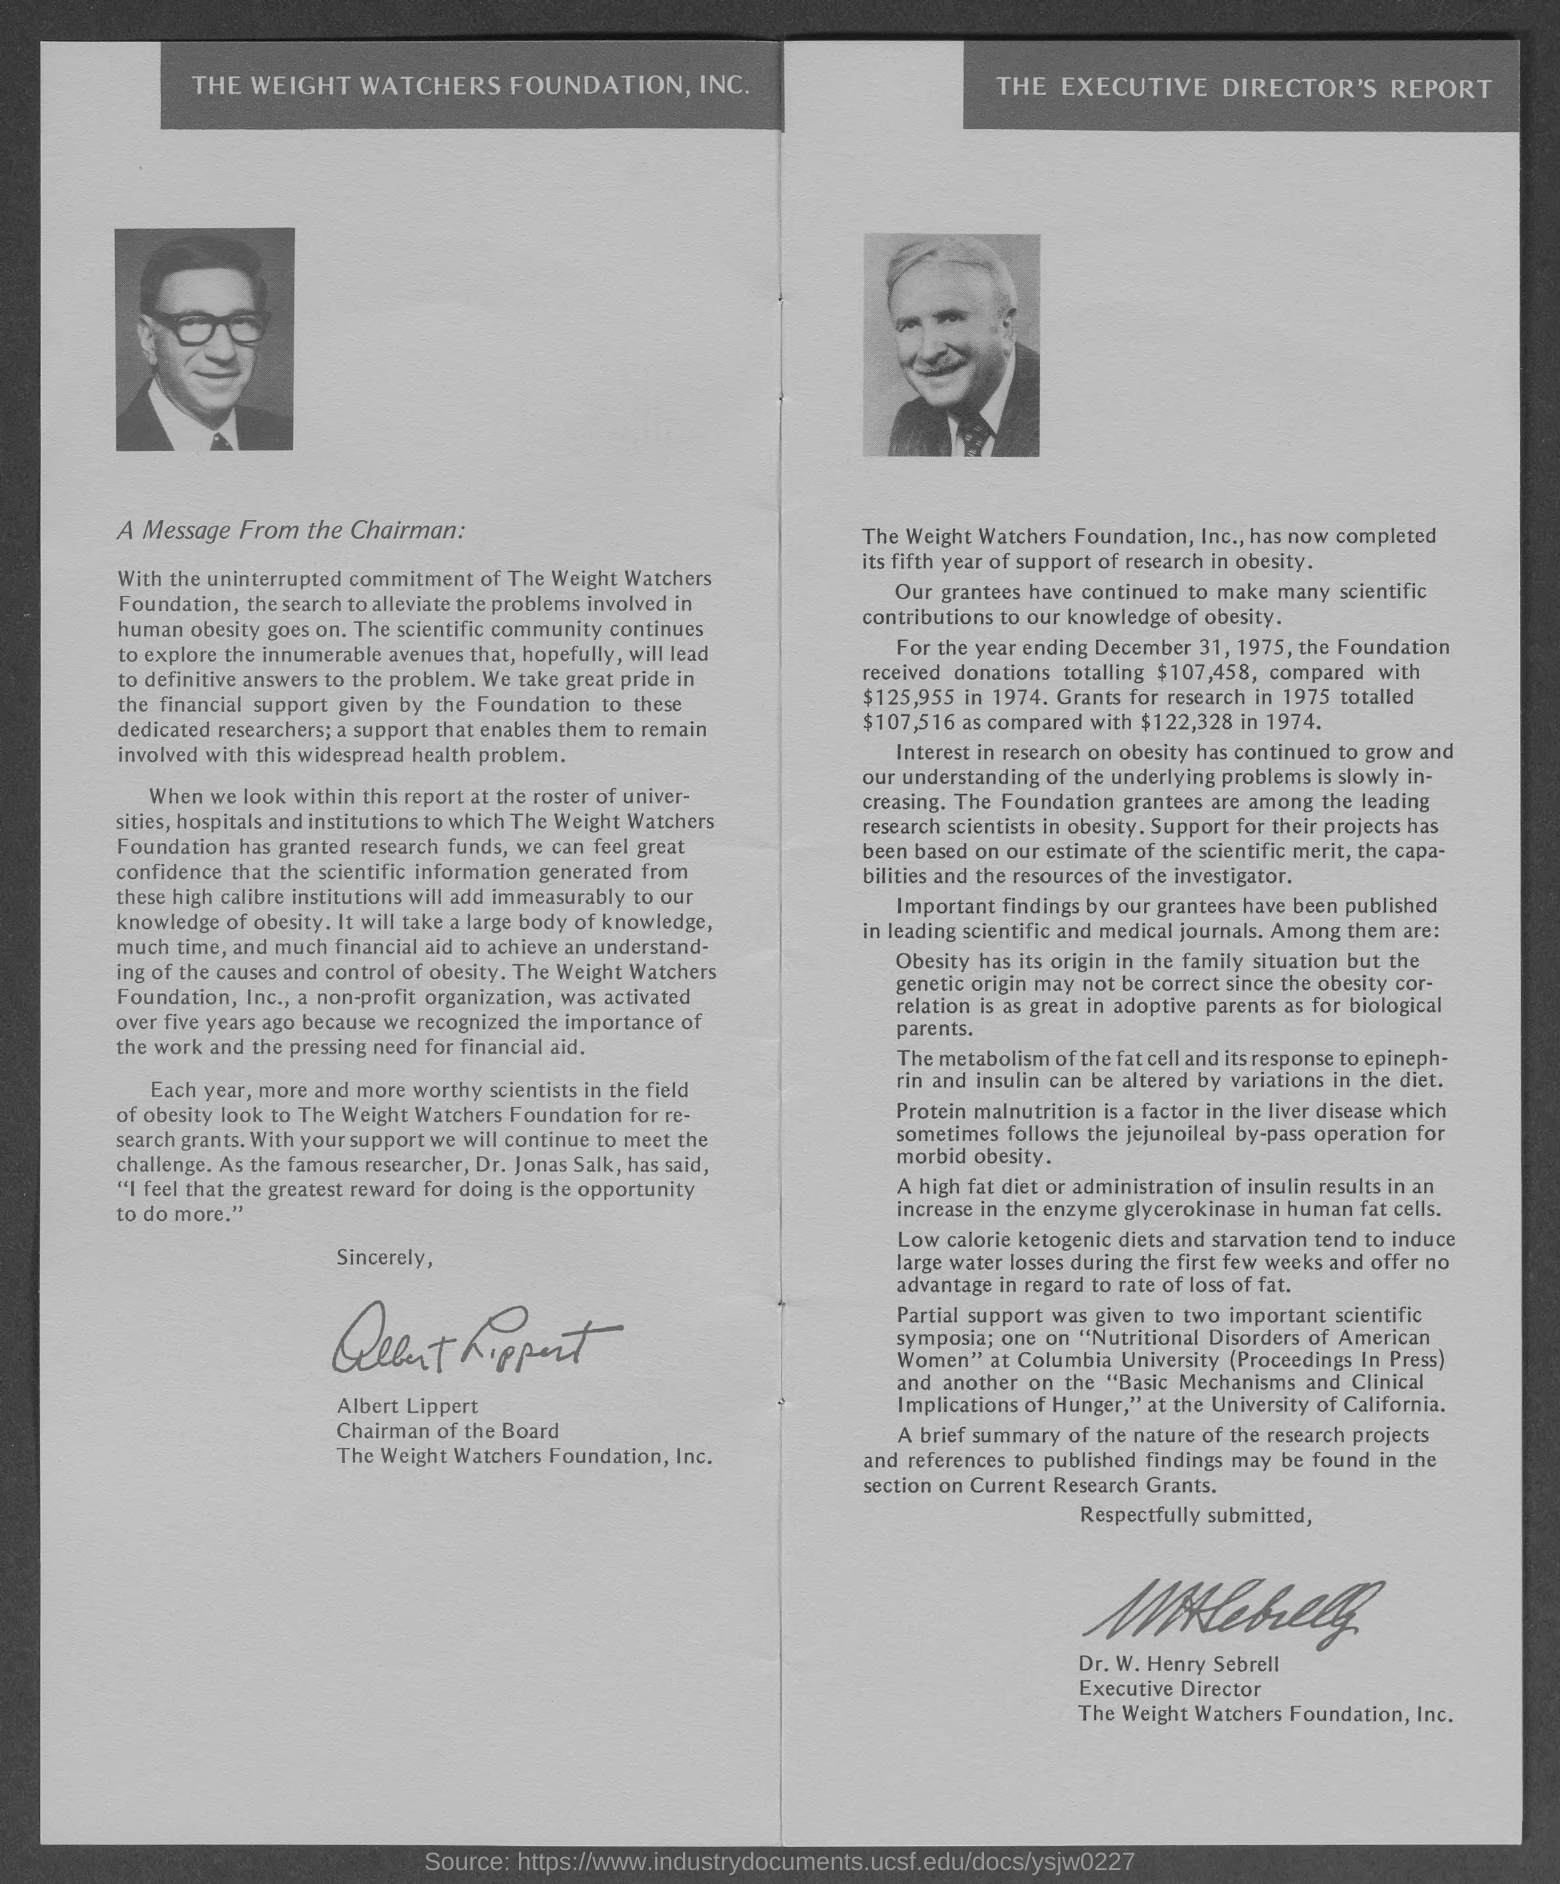Outline some significant characteristics in this image. The Foundation received a total of $107,458 in donations during the year ending December 31, 1975. The currency is $.. Dr. W. Henry Sebrell is the Executive Director. The photograph on the left side of the document is that of the Chairman. The photograph shown on the right side of the document is that of Dr. W. Henry Sebrell. 